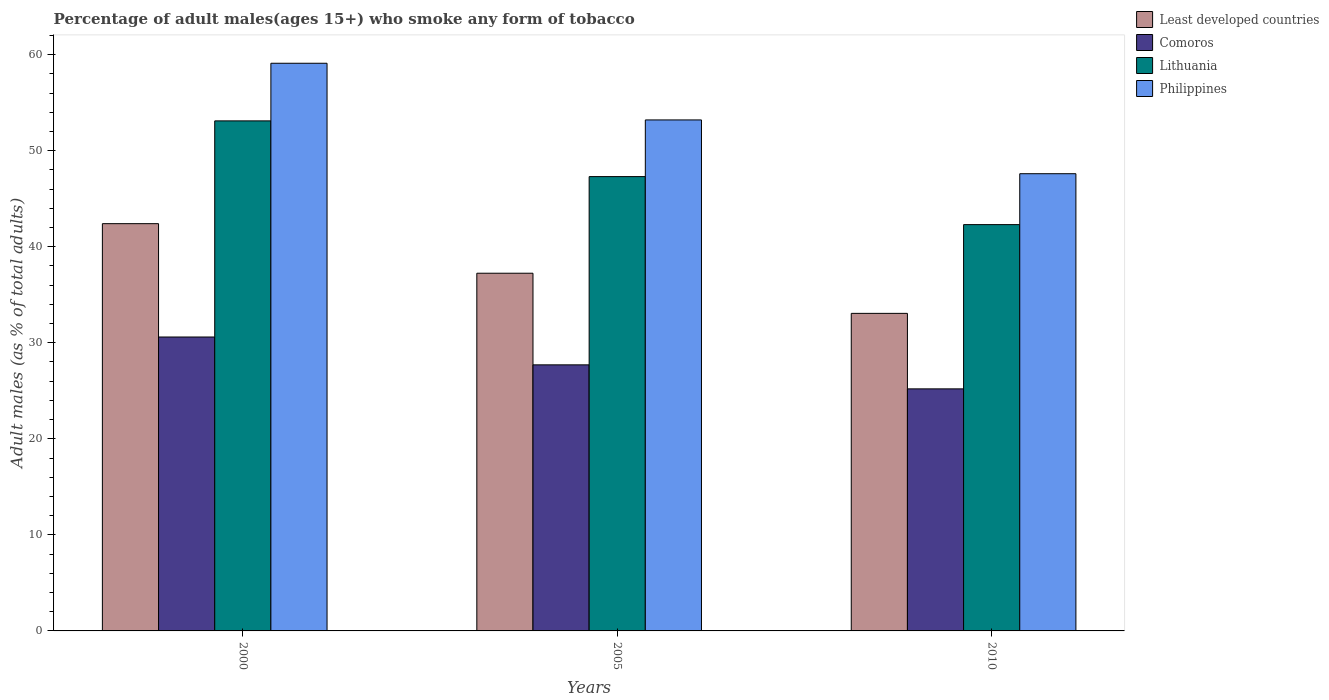How many different coloured bars are there?
Your answer should be very brief. 4. Are the number of bars on each tick of the X-axis equal?
Ensure brevity in your answer.  Yes. How many bars are there on the 1st tick from the left?
Your answer should be very brief. 4. What is the label of the 2nd group of bars from the left?
Provide a succinct answer. 2005. What is the percentage of adult males who smoke in Comoros in 2005?
Ensure brevity in your answer.  27.7. Across all years, what is the maximum percentage of adult males who smoke in Philippines?
Your response must be concise. 59.1. Across all years, what is the minimum percentage of adult males who smoke in Least developed countries?
Offer a terse response. 33.06. What is the total percentage of adult males who smoke in Philippines in the graph?
Your answer should be very brief. 159.9. What is the difference between the percentage of adult males who smoke in Least developed countries in 2005 and that in 2010?
Provide a succinct answer. 4.18. What is the difference between the percentage of adult males who smoke in Philippines in 2010 and the percentage of adult males who smoke in Lithuania in 2005?
Your answer should be very brief. 0.3. What is the average percentage of adult males who smoke in Lithuania per year?
Your answer should be compact. 47.57. In the year 2010, what is the difference between the percentage of adult males who smoke in Philippines and percentage of adult males who smoke in Comoros?
Offer a very short reply. 22.4. In how many years, is the percentage of adult males who smoke in Comoros greater than 36 %?
Your answer should be very brief. 0. What is the ratio of the percentage of adult males who smoke in Comoros in 2000 to that in 2010?
Ensure brevity in your answer.  1.21. Is the difference between the percentage of adult males who smoke in Philippines in 2000 and 2010 greater than the difference between the percentage of adult males who smoke in Comoros in 2000 and 2010?
Provide a short and direct response. Yes. What is the difference between the highest and the second highest percentage of adult males who smoke in Lithuania?
Your answer should be very brief. 5.8. What is the difference between the highest and the lowest percentage of adult males who smoke in Lithuania?
Keep it short and to the point. 10.8. In how many years, is the percentage of adult males who smoke in Comoros greater than the average percentage of adult males who smoke in Comoros taken over all years?
Your answer should be compact. 1. Is the sum of the percentage of adult males who smoke in Lithuania in 2000 and 2005 greater than the maximum percentage of adult males who smoke in Philippines across all years?
Make the answer very short. Yes. Is it the case that in every year, the sum of the percentage of adult males who smoke in Philippines and percentage of adult males who smoke in Lithuania is greater than the sum of percentage of adult males who smoke in Least developed countries and percentage of adult males who smoke in Comoros?
Offer a terse response. Yes. What does the 4th bar from the right in 2000 represents?
Make the answer very short. Least developed countries. How many years are there in the graph?
Your answer should be compact. 3. Are the values on the major ticks of Y-axis written in scientific E-notation?
Your answer should be very brief. No. Does the graph contain any zero values?
Ensure brevity in your answer.  No. Where does the legend appear in the graph?
Give a very brief answer. Top right. How are the legend labels stacked?
Provide a succinct answer. Vertical. What is the title of the graph?
Give a very brief answer. Percentage of adult males(ages 15+) who smoke any form of tobacco. Does "Grenada" appear as one of the legend labels in the graph?
Keep it short and to the point. No. What is the label or title of the X-axis?
Ensure brevity in your answer.  Years. What is the label or title of the Y-axis?
Keep it short and to the point. Adult males (as % of total adults). What is the Adult males (as % of total adults) of Least developed countries in 2000?
Make the answer very short. 42.4. What is the Adult males (as % of total adults) of Comoros in 2000?
Provide a short and direct response. 30.6. What is the Adult males (as % of total adults) in Lithuania in 2000?
Keep it short and to the point. 53.1. What is the Adult males (as % of total adults) of Philippines in 2000?
Your response must be concise. 59.1. What is the Adult males (as % of total adults) of Least developed countries in 2005?
Give a very brief answer. 37.24. What is the Adult males (as % of total adults) of Comoros in 2005?
Provide a succinct answer. 27.7. What is the Adult males (as % of total adults) of Lithuania in 2005?
Ensure brevity in your answer.  47.3. What is the Adult males (as % of total adults) of Philippines in 2005?
Your answer should be very brief. 53.2. What is the Adult males (as % of total adults) in Least developed countries in 2010?
Make the answer very short. 33.06. What is the Adult males (as % of total adults) in Comoros in 2010?
Your response must be concise. 25.2. What is the Adult males (as % of total adults) in Lithuania in 2010?
Provide a succinct answer. 42.3. What is the Adult males (as % of total adults) of Philippines in 2010?
Give a very brief answer. 47.6. Across all years, what is the maximum Adult males (as % of total adults) of Least developed countries?
Your response must be concise. 42.4. Across all years, what is the maximum Adult males (as % of total adults) in Comoros?
Ensure brevity in your answer.  30.6. Across all years, what is the maximum Adult males (as % of total adults) in Lithuania?
Keep it short and to the point. 53.1. Across all years, what is the maximum Adult males (as % of total adults) of Philippines?
Your response must be concise. 59.1. Across all years, what is the minimum Adult males (as % of total adults) of Least developed countries?
Your answer should be very brief. 33.06. Across all years, what is the minimum Adult males (as % of total adults) in Comoros?
Your answer should be compact. 25.2. Across all years, what is the minimum Adult males (as % of total adults) in Lithuania?
Give a very brief answer. 42.3. Across all years, what is the minimum Adult males (as % of total adults) in Philippines?
Ensure brevity in your answer.  47.6. What is the total Adult males (as % of total adults) of Least developed countries in the graph?
Keep it short and to the point. 112.7. What is the total Adult males (as % of total adults) of Comoros in the graph?
Make the answer very short. 83.5. What is the total Adult males (as % of total adults) of Lithuania in the graph?
Your answer should be very brief. 142.7. What is the total Adult males (as % of total adults) of Philippines in the graph?
Make the answer very short. 159.9. What is the difference between the Adult males (as % of total adults) of Least developed countries in 2000 and that in 2005?
Ensure brevity in your answer.  5.16. What is the difference between the Adult males (as % of total adults) in Comoros in 2000 and that in 2005?
Provide a succinct answer. 2.9. What is the difference between the Adult males (as % of total adults) of Lithuania in 2000 and that in 2005?
Provide a succinct answer. 5.8. What is the difference between the Adult males (as % of total adults) of Philippines in 2000 and that in 2005?
Your answer should be compact. 5.9. What is the difference between the Adult males (as % of total adults) of Least developed countries in 2000 and that in 2010?
Ensure brevity in your answer.  9.34. What is the difference between the Adult males (as % of total adults) of Lithuania in 2000 and that in 2010?
Ensure brevity in your answer.  10.8. What is the difference between the Adult males (as % of total adults) of Least developed countries in 2005 and that in 2010?
Keep it short and to the point. 4.18. What is the difference between the Adult males (as % of total adults) of Lithuania in 2005 and that in 2010?
Your response must be concise. 5. What is the difference between the Adult males (as % of total adults) of Philippines in 2005 and that in 2010?
Provide a succinct answer. 5.6. What is the difference between the Adult males (as % of total adults) in Least developed countries in 2000 and the Adult males (as % of total adults) in Comoros in 2005?
Your answer should be compact. 14.7. What is the difference between the Adult males (as % of total adults) in Least developed countries in 2000 and the Adult males (as % of total adults) in Lithuania in 2005?
Ensure brevity in your answer.  -4.9. What is the difference between the Adult males (as % of total adults) in Least developed countries in 2000 and the Adult males (as % of total adults) in Philippines in 2005?
Offer a terse response. -10.8. What is the difference between the Adult males (as % of total adults) of Comoros in 2000 and the Adult males (as % of total adults) of Lithuania in 2005?
Provide a short and direct response. -16.7. What is the difference between the Adult males (as % of total adults) in Comoros in 2000 and the Adult males (as % of total adults) in Philippines in 2005?
Keep it short and to the point. -22.6. What is the difference between the Adult males (as % of total adults) in Least developed countries in 2000 and the Adult males (as % of total adults) in Comoros in 2010?
Your response must be concise. 17.2. What is the difference between the Adult males (as % of total adults) of Least developed countries in 2000 and the Adult males (as % of total adults) of Lithuania in 2010?
Give a very brief answer. 0.1. What is the difference between the Adult males (as % of total adults) in Least developed countries in 2000 and the Adult males (as % of total adults) in Philippines in 2010?
Your response must be concise. -5.2. What is the difference between the Adult males (as % of total adults) in Comoros in 2000 and the Adult males (as % of total adults) in Philippines in 2010?
Give a very brief answer. -17. What is the difference between the Adult males (as % of total adults) in Lithuania in 2000 and the Adult males (as % of total adults) in Philippines in 2010?
Make the answer very short. 5.5. What is the difference between the Adult males (as % of total adults) in Least developed countries in 2005 and the Adult males (as % of total adults) in Comoros in 2010?
Provide a succinct answer. 12.04. What is the difference between the Adult males (as % of total adults) in Least developed countries in 2005 and the Adult males (as % of total adults) in Lithuania in 2010?
Your answer should be very brief. -5.06. What is the difference between the Adult males (as % of total adults) in Least developed countries in 2005 and the Adult males (as % of total adults) in Philippines in 2010?
Offer a terse response. -10.36. What is the difference between the Adult males (as % of total adults) in Comoros in 2005 and the Adult males (as % of total adults) in Lithuania in 2010?
Give a very brief answer. -14.6. What is the difference between the Adult males (as % of total adults) of Comoros in 2005 and the Adult males (as % of total adults) of Philippines in 2010?
Ensure brevity in your answer.  -19.9. What is the average Adult males (as % of total adults) of Least developed countries per year?
Make the answer very short. 37.57. What is the average Adult males (as % of total adults) in Comoros per year?
Keep it short and to the point. 27.83. What is the average Adult males (as % of total adults) in Lithuania per year?
Provide a succinct answer. 47.57. What is the average Adult males (as % of total adults) of Philippines per year?
Offer a very short reply. 53.3. In the year 2000, what is the difference between the Adult males (as % of total adults) of Least developed countries and Adult males (as % of total adults) of Comoros?
Your answer should be compact. 11.8. In the year 2000, what is the difference between the Adult males (as % of total adults) in Least developed countries and Adult males (as % of total adults) in Lithuania?
Your answer should be very brief. -10.7. In the year 2000, what is the difference between the Adult males (as % of total adults) in Least developed countries and Adult males (as % of total adults) in Philippines?
Provide a succinct answer. -16.7. In the year 2000, what is the difference between the Adult males (as % of total adults) of Comoros and Adult males (as % of total adults) of Lithuania?
Ensure brevity in your answer.  -22.5. In the year 2000, what is the difference between the Adult males (as % of total adults) of Comoros and Adult males (as % of total adults) of Philippines?
Keep it short and to the point. -28.5. In the year 2000, what is the difference between the Adult males (as % of total adults) in Lithuania and Adult males (as % of total adults) in Philippines?
Keep it short and to the point. -6. In the year 2005, what is the difference between the Adult males (as % of total adults) in Least developed countries and Adult males (as % of total adults) in Comoros?
Offer a terse response. 9.54. In the year 2005, what is the difference between the Adult males (as % of total adults) of Least developed countries and Adult males (as % of total adults) of Lithuania?
Provide a short and direct response. -10.06. In the year 2005, what is the difference between the Adult males (as % of total adults) in Least developed countries and Adult males (as % of total adults) in Philippines?
Your response must be concise. -15.96. In the year 2005, what is the difference between the Adult males (as % of total adults) of Comoros and Adult males (as % of total adults) of Lithuania?
Make the answer very short. -19.6. In the year 2005, what is the difference between the Adult males (as % of total adults) in Comoros and Adult males (as % of total adults) in Philippines?
Your answer should be compact. -25.5. In the year 2005, what is the difference between the Adult males (as % of total adults) in Lithuania and Adult males (as % of total adults) in Philippines?
Make the answer very short. -5.9. In the year 2010, what is the difference between the Adult males (as % of total adults) in Least developed countries and Adult males (as % of total adults) in Comoros?
Provide a short and direct response. 7.86. In the year 2010, what is the difference between the Adult males (as % of total adults) in Least developed countries and Adult males (as % of total adults) in Lithuania?
Your answer should be very brief. -9.24. In the year 2010, what is the difference between the Adult males (as % of total adults) of Least developed countries and Adult males (as % of total adults) of Philippines?
Provide a succinct answer. -14.54. In the year 2010, what is the difference between the Adult males (as % of total adults) in Comoros and Adult males (as % of total adults) in Lithuania?
Offer a terse response. -17.1. In the year 2010, what is the difference between the Adult males (as % of total adults) of Comoros and Adult males (as % of total adults) of Philippines?
Make the answer very short. -22.4. What is the ratio of the Adult males (as % of total adults) of Least developed countries in 2000 to that in 2005?
Provide a succinct answer. 1.14. What is the ratio of the Adult males (as % of total adults) in Comoros in 2000 to that in 2005?
Your answer should be compact. 1.1. What is the ratio of the Adult males (as % of total adults) in Lithuania in 2000 to that in 2005?
Offer a terse response. 1.12. What is the ratio of the Adult males (as % of total adults) of Philippines in 2000 to that in 2005?
Your answer should be very brief. 1.11. What is the ratio of the Adult males (as % of total adults) in Least developed countries in 2000 to that in 2010?
Keep it short and to the point. 1.28. What is the ratio of the Adult males (as % of total adults) in Comoros in 2000 to that in 2010?
Offer a terse response. 1.21. What is the ratio of the Adult males (as % of total adults) of Lithuania in 2000 to that in 2010?
Provide a succinct answer. 1.26. What is the ratio of the Adult males (as % of total adults) of Philippines in 2000 to that in 2010?
Give a very brief answer. 1.24. What is the ratio of the Adult males (as % of total adults) of Least developed countries in 2005 to that in 2010?
Offer a terse response. 1.13. What is the ratio of the Adult males (as % of total adults) in Comoros in 2005 to that in 2010?
Offer a terse response. 1.1. What is the ratio of the Adult males (as % of total adults) of Lithuania in 2005 to that in 2010?
Provide a short and direct response. 1.12. What is the ratio of the Adult males (as % of total adults) in Philippines in 2005 to that in 2010?
Give a very brief answer. 1.12. What is the difference between the highest and the second highest Adult males (as % of total adults) in Least developed countries?
Offer a very short reply. 5.16. What is the difference between the highest and the second highest Adult males (as % of total adults) in Lithuania?
Your answer should be very brief. 5.8. What is the difference between the highest and the lowest Adult males (as % of total adults) of Least developed countries?
Your response must be concise. 9.34. What is the difference between the highest and the lowest Adult males (as % of total adults) of Comoros?
Your answer should be compact. 5.4. What is the difference between the highest and the lowest Adult males (as % of total adults) of Lithuania?
Your answer should be very brief. 10.8. What is the difference between the highest and the lowest Adult males (as % of total adults) of Philippines?
Offer a very short reply. 11.5. 